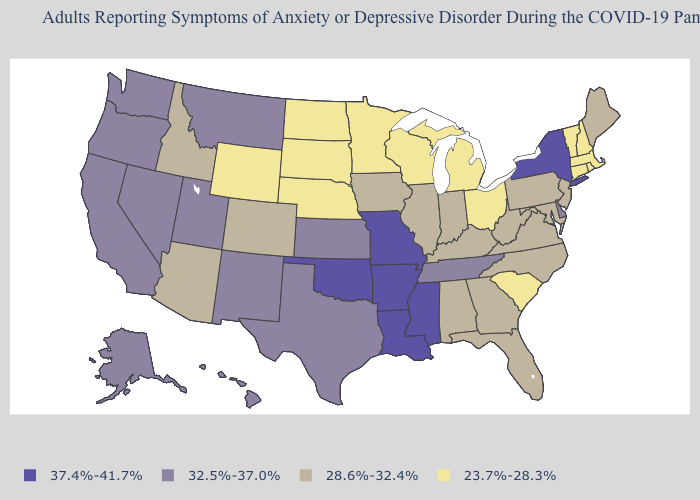What is the value of Georgia?
Answer briefly. 28.6%-32.4%. What is the lowest value in the West?
Short answer required. 23.7%-28.3%. Which states hav the highest value in the West?
Answer briefly. Alaska, California, Hawaii, Montana, Nevada, New Mexico, Oregon, Utah, Washington. What is the value of Connecticut?
Write a very short answer. 23.7%-28.3%. Which states have the lowest value in the South?
Be succinct. South Carolina. Among the states that border Mississippi , does Alabama have the lowest value?
Give a very brief answer. Yes. Does the first symbol in the legend represent the smallest category?
Quick response, please. No. Does Illinois have the same value as Oregon?
Keep it brief. No. What is the highest value in states that border Wisconsin?
Write a very short answer. 28.6%-32.4%. What is the value of Connecticut?
Concise answer only. 23.7%-28.3%. Does New York have the same value as Kentucky?
Quick response, please. No. What is the value of Montana?
Keep it brief. 32.5%-37.0%. Does Ohio have a higher value than Wisconsin?
Be succinct. No. Name the states that have a value in the range 23.7%-28.3%?
Answer briefly. Connecticut, Massachusetts, Michigan, Minnesota, Nebraska, New Hampshire, North Dakota, Ohio, Rhode Island, South Carolina, South Dakota, Vermont, Wisconsin, Wyoming. Does Hawaii have the same value as Ohio?
Write a very short answer. No. 